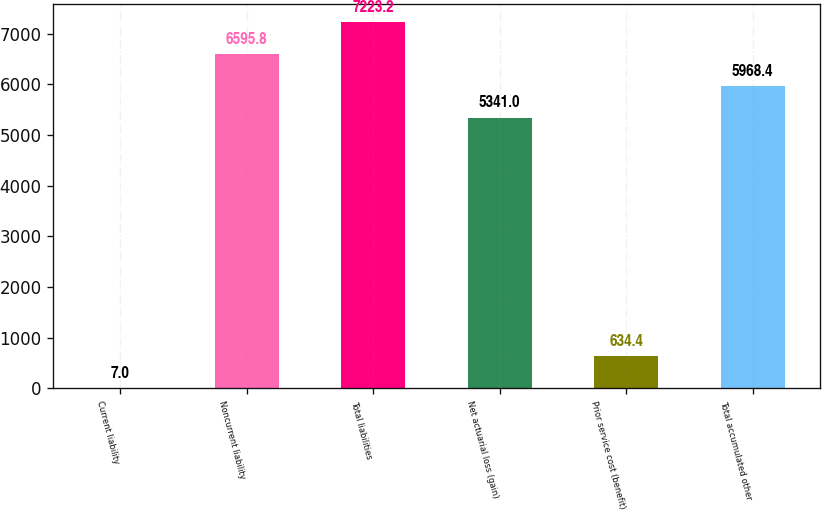Convert chart to OTSL. <chart><loc_0><loc_0><loc_500><loc_500><bar_chart><fcel>Current liability<fcel>Noncurrent liability<fcel>Total liabilities<fcel>Net actuarial loss (gain)<fcel>Prior service cost (benefit)<fcel>Total accumulated other<nl><fcel>7<fcel>6595.8<fcel>7223.2<fcel>5341<fcel>634.4<fcel>5968.4<nl></chart> 